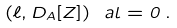Convert formula to latex. <formula><loc_0><loc_0><loc_500><loc_500>( \ell , D _ { A } [ Z ] ) _ { \ } a l = 0 \, .</formula> 